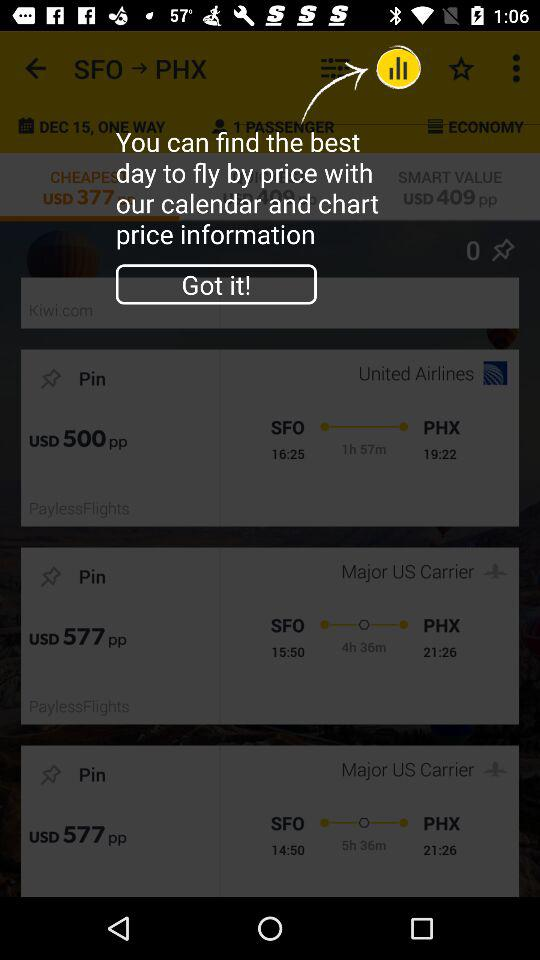How many hours does the longest flight take?
Answer the question using a single word or phrase. 5h 36m 